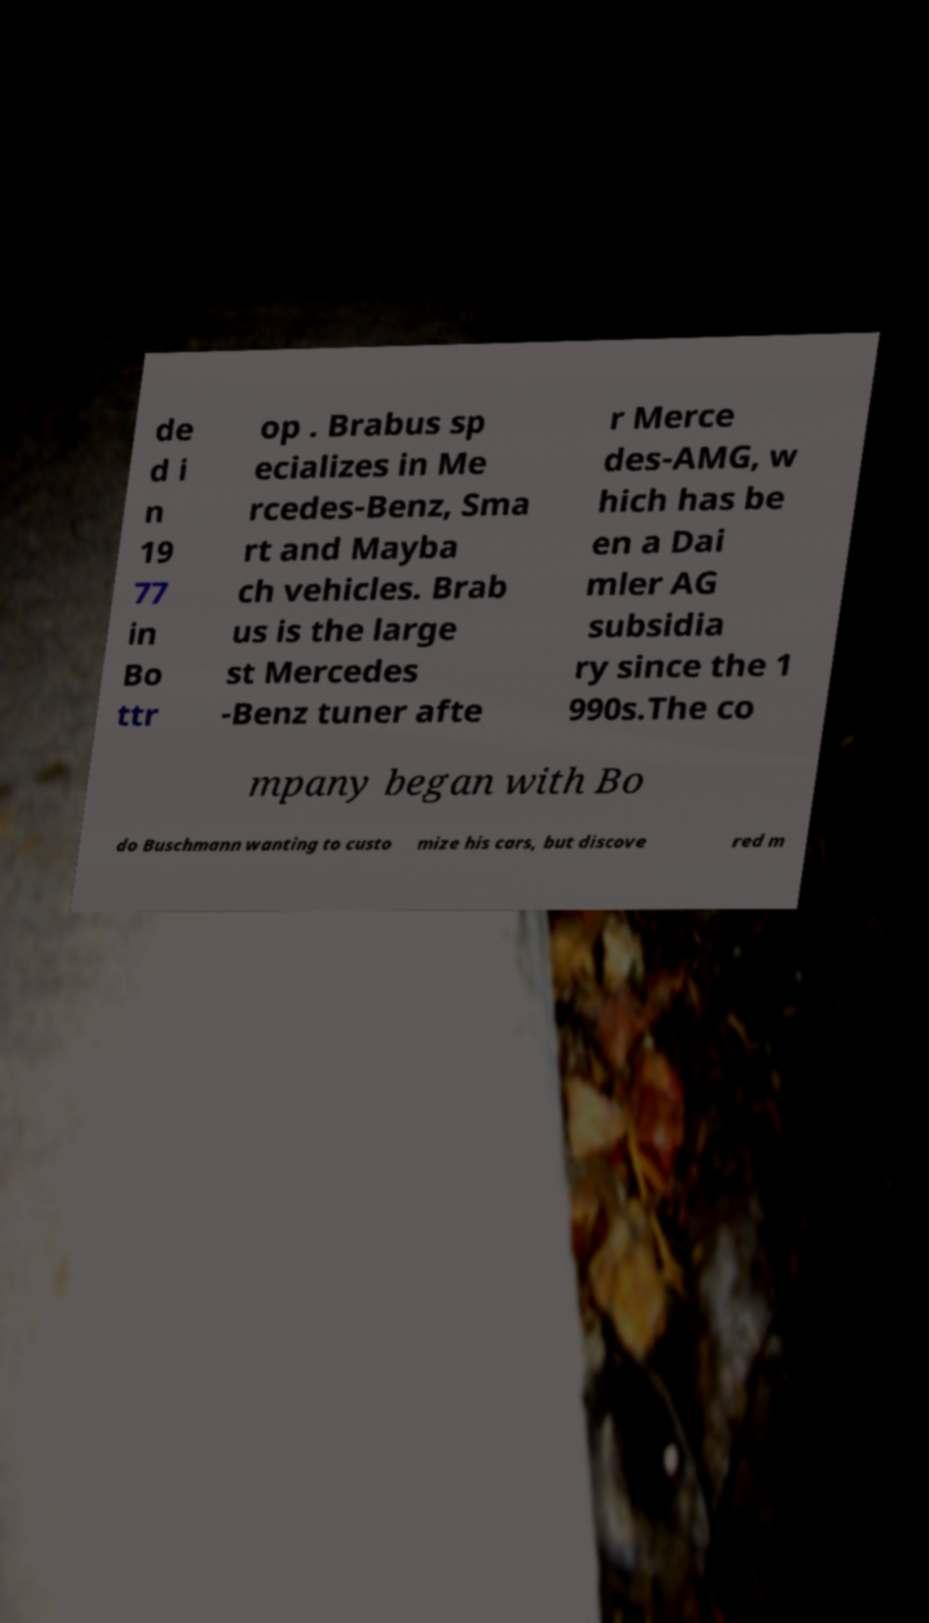Can you accurately transcribe the text from the provided image for me? de d i n 19 77 in Bo ttr op . Brabus sp ecializes in Me rcedes-Benz, Sma rt and Mayba ch vehicles. Brab us is the large st Mercedes -Benz tuner afte r Merce des-AMG, w hich has be en a Dai mler AG subsidia ry since the 1 990s.The co mpany began with Bo do Buschmann wanting to custo mize his cars, but discove red m 